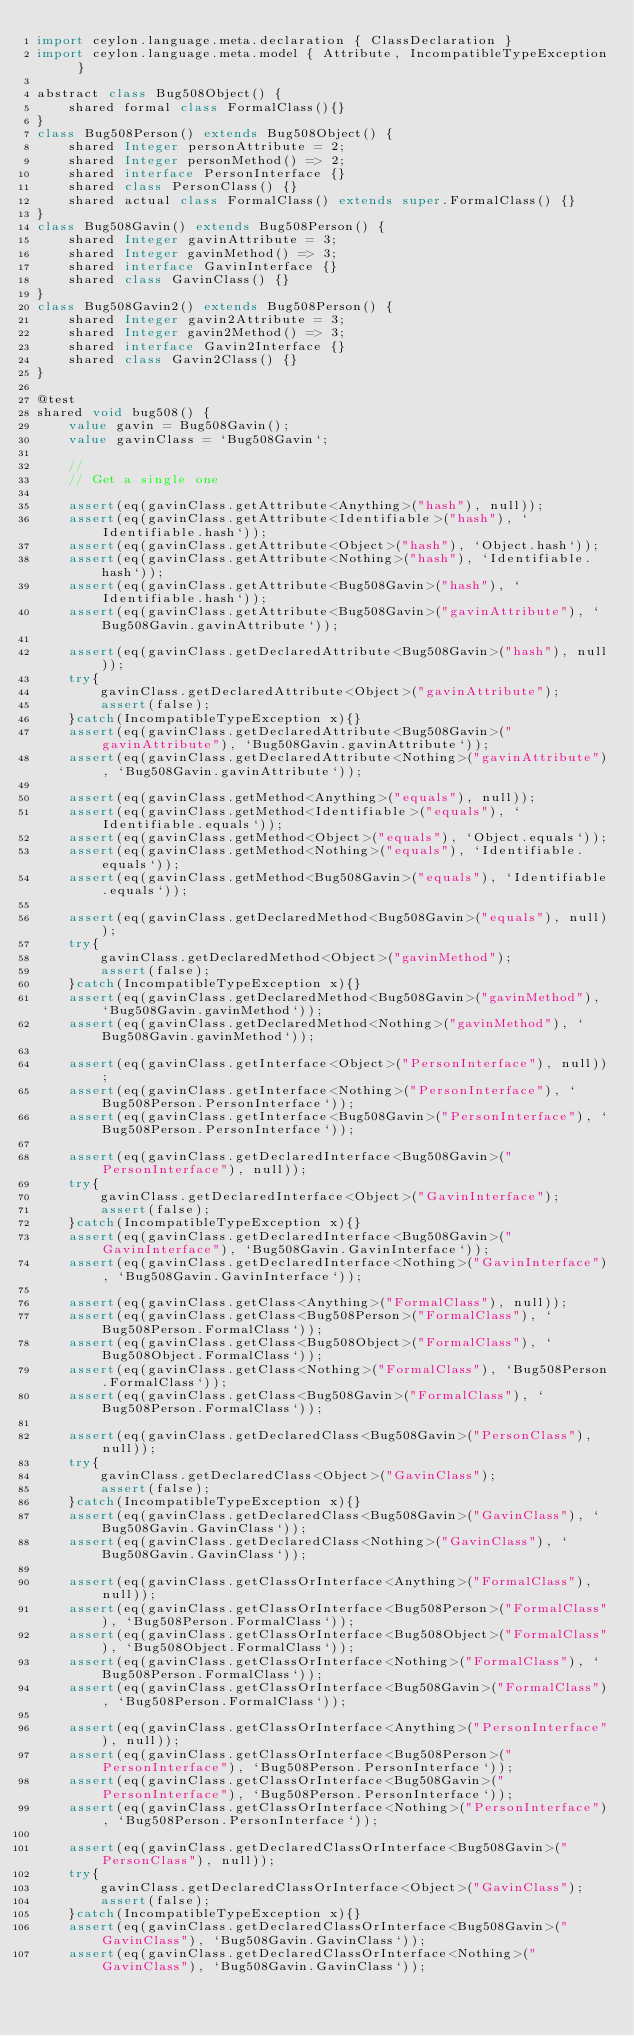Convert code to text. <code><loc_0><loc_0><loc_500><loc_500><_Ceylon_>import ceylon.language.meta.declaration { ClassDeclaration }
import ceylon.language.meta.model { Attribute, IncompatibleTypeException }

abstract class Bug508Object() {
    shared formal class FormalClass(){}
}
class Bug508Person() extends Bug508Object() {
    shared Integer personAttribute = 2;
    shared Integer personMethod() => 2;
    shared interface PersonInterface {}
    shared class PersonClass() {}
    shared actual class FormalClass() extends super.FormalClass() {}
}
class Bug508Gavin() extends Bug508Person() {
    shared Integer gavinAttribute = 3;
    shared Integer gavinMethod() => 3;
    shared interface GavinInterface {}
    shared class GavinClass() {}
}
class Bug508Gavin2() extends Bug508Person() {
    shared Integer gavin2Attribute = 3;
    shared Integer gavin2Method() => 3;
    shared interface Gavin2Interface {}
    shared class Gavin2Class() {}
}

@test
shared void bug508() {
    value gavin = Bug508Gavin();
    value gavinClass = `Bug508Gavin`;
    
    //
    // Get a single one
    
    assert(eq(gavinClass.getAttribute<Anything>("hash"), null));
    assert(eq(gavinClass.getAttribute<Identifiable>("hash"), `Identifiable.hash`));
    assert(eq(gavinClass.getAttribute<Object>("hash"), `Object.hash`));
    assert(eq(gavinClass.getAttribute<Nothing>("hash"), `Identifiable.hash`));
    assert(eq(gavinClass.getAttribute<Bug508Gavin>("hash"), `Identifiable.hash`));
    assert(eq(gavinClass.getAttribute<Bug508Gavin>("gavinAttribute"), `Bug508Gavin.gavinAttribute`));

    assert(eq(gavinClass.getDeclaredAttribute<Bug508Gavin>("hash"), null));
    try{
        gavinClass.getDeclaredAttribute<Object>("gavinAttribute");
        assert(false);
    }catch(IncompatibleTypeException x){}
    assert(eq(gavinClass.getDeclaredAttribute<Bug508Gavin>("gavinAttribute"), `Bug508Gavin.gavinAttribute`));
    assert(eq(gavinClass.getDeclaredAttribute<Nothing>("gavinAttribute"), `Bug508Gavin.gavinAttribute`));

    assert(eq(gavinClass.getMethod<Anything>("equals"), null));
    assert(eq(gavinClass.getMethod<Identifiable>("equals"), `Identifiable.equals`));
    assert(eq(gavinClass.getMethod<Object>("equals"), `Object.equals`));
    assert(eq(gavinClass.getMethod<Nothing>("equals"), `Identifiable.equals`));
    assert(eq(gavinClass.getMethod<Bug508Gavin>("equals"), `Identifiable.equals`));

    assert(eq(gavinClass.getDeclaredMethod<Bug508Gavin>("equals"), null));
    try{
        gavinClass.getDeclaredMethod<Object>("gavinMethod");
        assert(false);
    }catch(IncompatibleTypeException x){}
    assert(eq(gavinClass.getDeclaredMethod<Bug508Gavin>("gavinMethod"), `Bug508Gavin.gavinMethod`));
    assert(eq(gavinClass.getDeclaredMethod<Nothing>("gavinMethod"), `Bug508Gavin.gavinMethod`));

    assert(eq(gavinClass.getInterface<Object>("PersonInterface"), null));
    assert(eq(gavinClass.getInterface<Nothing>("PersonInterface"), `Bug508Person.PersonInterface`));
    assert(eq(gavinClass.getInterface<Bug508Gavin>("PersonInterface"), `Bug508Person.PersonInterface`));

    assert(eq(gavinClass.getDeclaredInterface<Bug508Gavin>("PersonInterface"), null));
    try{
        gavinClass.getDeclaredInterface<Object>("GavinInterface");
        assert(false);
    }catch(IncompatibleTypeException x){}
    assert(eq(gavinClass.getDeclaredInterface<Bug508Gavin>("GavinInterface"), `Bug508Gavin.GavinInterface`));
    assert(eq(gavinClass.getDeclaredInterface<Nothing>("GavinInterface"), `Bug508Gavin.GavinInterface`));

    assert(eq(gavinClass.getClass<Anything>("FormalClass"), null));
    assert(eq(gavinClass.getClass<Bug508Person>("FormalClass"), `Bug508Person.FormalClass`));
    assert(eq(gavinClass.getClass<Bug508Object>("FormalClass"), `Bug508Object.FormalClass`));
    assert(eq(gavinClass.getClass<Nothing>("FormalClass"), `Bug508Person.FormalClass`));
    assert(eq(gavinClass.getClass<Bug508Gavin>("FormalClass"), `Bug508Person.FormalClass`));

    assert(eq(gavinClass.getDeclaredClass<Bug508Gavin>("PersonClass"), null));
    try{
        gavinClass.getDeclaredClass<Object>("GavinClass");
        assert(false);
    }catch(IncompatibleTypeException x){}
    assert(eq(gavinClass.getDeclaredClass<Bug508Gavin>("GavinClass"), `Bug508Gavin.GavinClass`));
    assert(eq(gavinClass.getDeclaredClass<Nothing>("GavinClass"), `Bug508Gavin.GavinClass`));

    assert(eq(gavinClass.getClassOrInterface<Anything>("FormalClass"), null));
    assert(eq(gavinClass.getClassOrInterface<Bug508Person>("FormalClass"), `Bug508Person.FormalClass`));
    assert(eq(gavinClass.getClassOrInterface<Bug508Object>("FormalClass"), `Bug508Object.FormalClass`));
    assert(eq(gavinClass.getClassOrInterface<Nothing>("FormalClass"), `Bug508Person.FormalClass`));
    assert(eq(gavinClass.getClassOrInterface<Bug508Gavin>("FormalClass"), `Bug508Person.FormalClass`));

    assert(eq(gavinClass.getClassOrInterface<Anything>("PersonInterface"), null));
    assert(eq(gavinClass.getClassOrInterface<Bug508Person>("PersonInterface"), `Bug508Person.PersonInterface`));
    assert(eq(gavinClass.getClassOrInterface<Bug508Gavin>("PersonInterface"), `Bug508Person.PersonInterface`));
    assert(eq(gavinClass.getClassOrInterface<Nothing>("PersonInterface"), `Bug508Person.PersonInterface`));
    
    assert(eq(gavinClass.getDeclaredClassOrInterface<Bug508Gavin>("PersonClass"), null));
    try{
        gavinClass.getDeclaredClassOrInterface<Object>("GavinClass");
        assert(false);
    }catch(IncompatibleTypeException x){}
    assert(eq(gavinClass.getDeclaredClassOrInterface<Bug508Gavin>("GavinClass"), `Bug508Gavin.GavinClass`));
    assert(eq(gavinClass.getDeclaredClassOrInterface<Nothing>("GavinClass"), `Bug508Gavin.GavinClass`));
</code> 